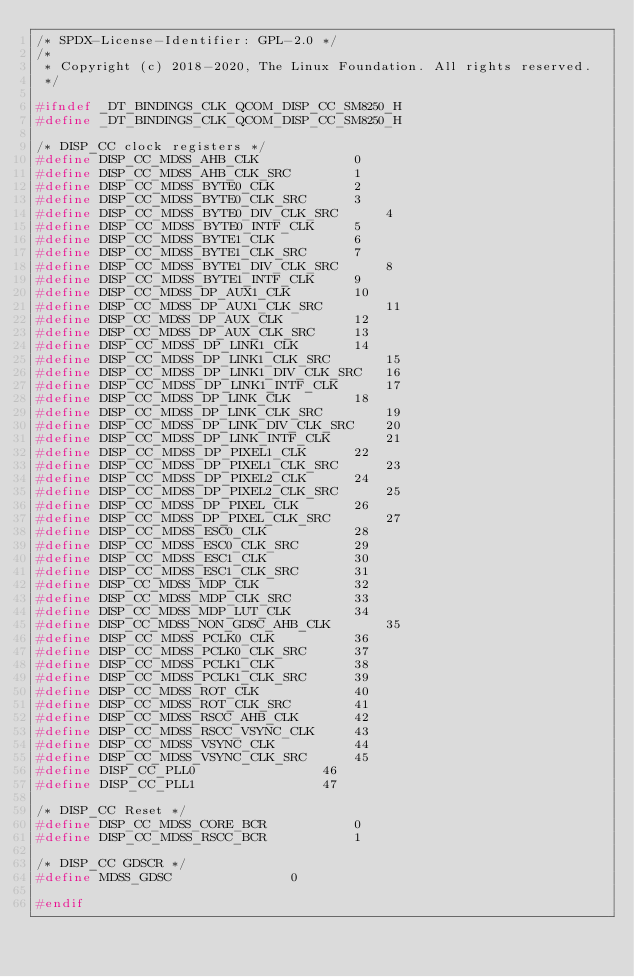<code> <loc_0><loc_0><loc_500><loc_500><_C_>/* SPDX-License-Identifier: GPL-2.0 */
/*
 * Copyright (c) 2018-2020, The Linux Foundation. All rights reserved.
 */

#ifndef _DT_BINDINGS_CLK_QCOM_DISP_CC_SM8250_H
#define _DT_BINDINGS_CLK_QCOM_DISP_CC_SM8250_H

/* DISP_CC clock registers */
#define DISP_CC_MDSS_AHB_CLK			0
#define DISP_CC_MDSS_AHB_CLK_SRC		1
#define DISP_CC_MDSS_BYTE0_CLK			2
#define DISP_CC_MDSS_BYTE0_CLK_SRC		3
#define DISP_CC_MDSS_BYTE0_DIV_CLK_SRC		4
#define DISP_CC_MDSS_BYTE0_INTF_CLK		5
#define DISP_CC_MDSS_BYTE1_CLK			6
#define DISP_CC_MDSS_BYTE1_CLK_SRC		7
#define DISP_CC_MDSS_BYTE1_DIV_CLK_SRC		8
#define DISP_CC_MDSS_BYTE1_INTF_CLK		9
#define DISP_CC_MDSS_DP_AUX1_CLK		10
#define DISP_CC_MDSS_DP_AUX1_CLK_SRC		11
#define DISP_CC_MDSS_DP_AUX_CLK			12
#define DISP_CC_MDSS_DP_AUX_CLK_SRC		13
#define DISP_CC_MDSS_DP_LINK1_CLK		14
#define DISP_CC_MDSS_DP_LINK1_CLK_SRC		15
#define DISP_CC_MDSS_DP_LINK1_DIV_CLK_SRC	16
#define DISP_CC_MDSS_DP_LINK1_INTF_CLK		17
#define DISP_CC_MDSS_DP_LINK_CLK		18
#define DISP_CC_MDSS_DP_LINK_CLK_SRC		19
#define DISP_CC_MDSS_DP_LINK_DIV_CLK_SRC	20
#define DISP_CC_MDSS_DP_LINK_INTF_CLK		21
#define DISP_CC_MDSS_DP_PIXEL1_CLK		22
#define DISP_CC_MDSS_DP_PIXEL1_CLK_SRC		23
#define DISP_CC_MDSS_DP_PIXEL2_CLK		24
#define DISP_CC_MDSS_DP_PIXEL2_CLK_SRC		25
#define DISP_CC_MDSS_DP_PIXEL_CLK		26
#define DISP_CC_MDSS_DP_PIXEL_CLK_SRC		27
#define DISP_CC_MDSS_ESC0_CLK			28
#define DISP_CC_MDSS_ESC0_CLK_SRC		29
#define DISP_CC_MDSS_ESC1_CLK			30
#define DISP_CC_MDSS_ESC1_CLK_SRC		31
#define DISP_CC_MDSS_MDP_CLK			32
#define DISP_CC_MDSS_MDP_CLK_SRC		33
#define DISP_CC_MDSS_MDP_LUT_CLK		34
#define DISP_CC_MDSS_NON_GDSC_AHB_CLK		35
#define DISP_CC_MDSS_PCLK0_CLK			36
#define DISP_CC_MDSS_PCLK0_CLK_SRC		37
#define DISP_CC_MDSS_PCLK1_CLK			38
#define DISP_CC_MDSS_PCLK1_CLK_SRC		39
#define DISP_CC_MDSS_ROT_CLK			40
#define DISP_CC_MDSS_ROT_CLK_SRC		41
#define DISP_CC_MDSS_RSCC_AHB_CLK		42
#define DISP_CC_MDSS_RSCC_VSYNC_CLK		43
#define DISP_CC_MDSS_VSYNC_CLK			44
#define DISP_CC_MDSS_VSYNC_CLK_SRC		45
#define DISP_CC_PLL0				46
#define DISP_CC_PLL1				47

/* DISP_CC Reset */
#define DISP_CC_MDSS_CORE_BCR			0
#define DISP_CC_MDSS_RSCC_BCR			1

/* DISP_CC GDSCR */
#define MDSS_GDSC				0

#endif
</code> 